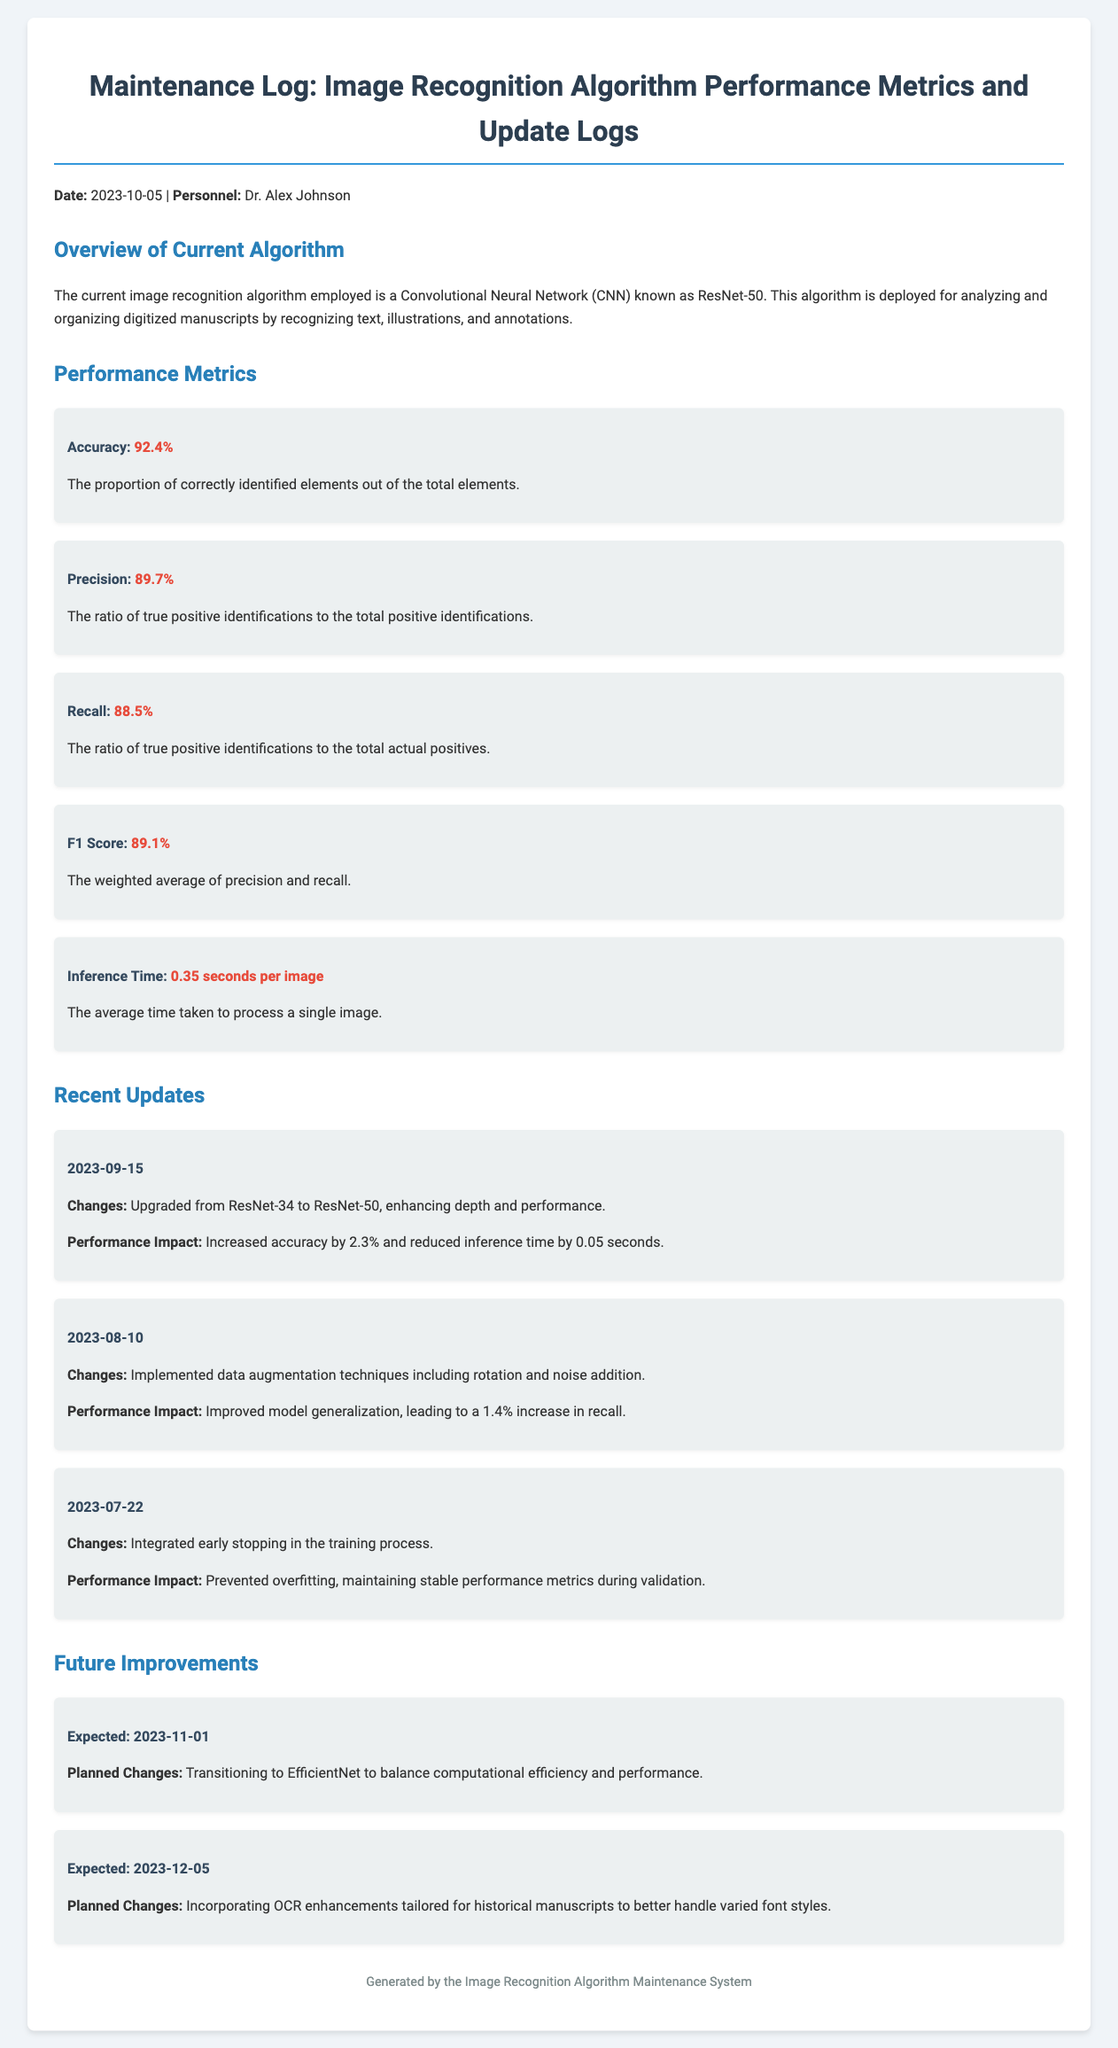What is the current algorithm used? The document states that the current algorithm employed is a Convolutional Neural Network (CNN) known as ResNet-50.
Answer: ResNet-50 What is the accuracy of the algorithm? The accuracy metric listed in the document is 92.4%.
Answer: 92.4% When was the algorithm upgraded from ResNet-34 to ResNet-50? The upgrade date mentioned in the document is September 15, 2023.
Answer: 2023-09-15 What is the inference time per image? According to the performance metrics, the inference time is 0.35 seconds per image.
Answer: 0.35 seconds per image What performance impact was observed with the data augmentation implemented on August 10, 2023? The performance impact stated is an increase in recall by 1.4%.
Answer: 1.4% increase in recall What is the expected date for the transition to EfficientNet? The document notes that the expected date for this transition is November 1, 2023.
Answer: 2023-11-01 Why was early stopping integrated during the training process? The reason provided is to prevent overfitting and maintain stable performance metrics.
Answer: Prevented overfitting How much did the accuracy increase after upgrading to ResNet-50? The increase in accuracy after the upgrade is 2.3%.
Answer: 2.3% What is the overall purpose of the algorithm according to the overview? The overview describes the purpose as analyzing and organizing digitized manuscripts.
Answer: Analyzing and organizing digitized manuscripts 